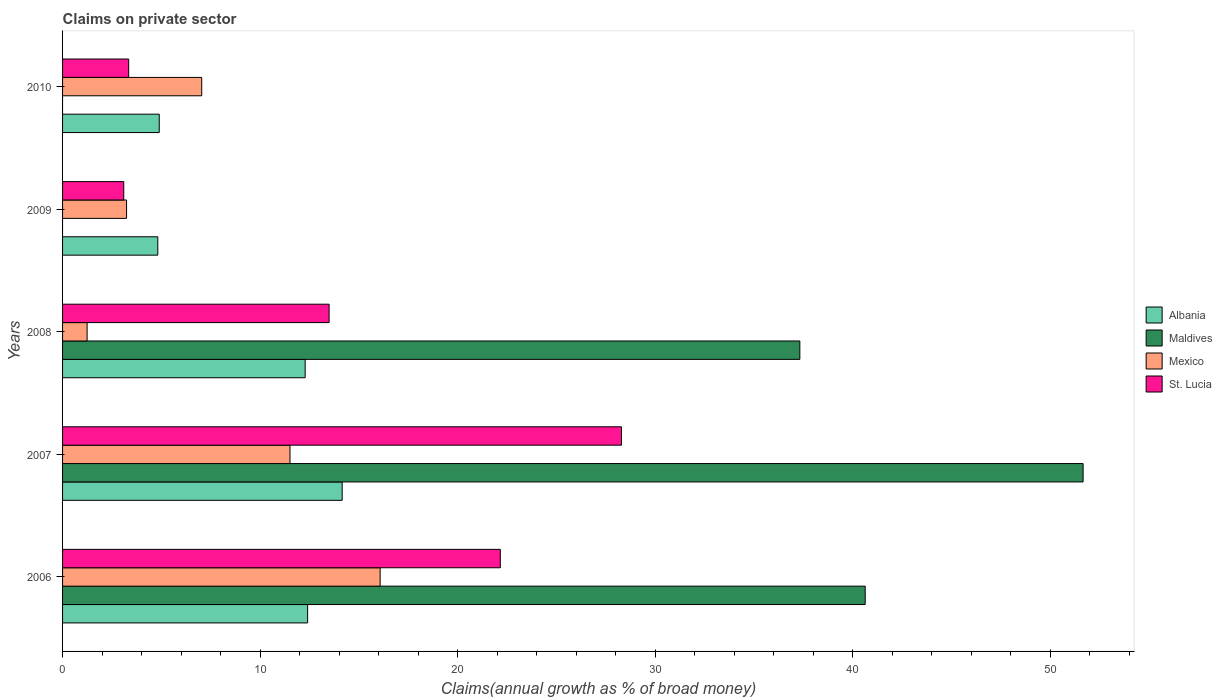How many different coloured bars are there?
Your answer should be very brief. 4. Are the number of bars per tick equal to the number of legend labels?
Keep it short and to the point. No. Are the number of bars on each tick of the Y-axis equal?
Ensure brevity in your answer.  No. How many bars are there on the 1st tick from the top?
Give a very brief answer. 3. How many bars are there on the 4th tick from the bottom?
Give a very brief answer. 3. In how many cases, is the number of bars for a given year not equal to the number of legend labels?
Your answer should be compact. 2. What is the percentage of broad money claimed on private sector in St. Lucia in 2008?
Your answer should be compact. 13.49. Across all years, what is the maximum percentage of broad money claimed on private sector in St. Lucia?
Provide a succinct answer. 28.29. Across all years, what is the minimum percentage of broad money claimed on private sector in Mexico?
Your response must be concise. 1.24. In which year was the percentage of broad money claimed on private sector in Albania maximum?
Offer a terse response. 2007. What is the total percentage of broad money claimed on private sector in Maldives in the graph?
Your response must be concise. 129.62. What is the difference between the percentage of broad money claimed on private sector in Maldives in 2006 and that in 2008?
Your response must be concise. 3.31. What is the difference between the percentage of broad money claimed on private sector in Maldives in 2006 and the percentage of broad money claimed on private sector in St. Lucia in 2009?
Offer a terse response. 37.53. What is the average percentage of broad money claimed on private sector in Albania per year?
Offer a terse response. 9.71. In the year 2006, what is the difference between the percentage of broad money claimed on private sector in Mexico and percentage of broad money claimed on private sector in Albania?
Ensure brevity in your answer.  3.67. What is the ratio of the percentage of broad money claimed on private sector in Mexico in 2006 to that in 2007?
Ensure brevity in your answer.  1.4. Is the percentage of broad money claimed on private sector in Albania in 2006 less than that in 2009?
Give a very brief answer. No. Is the difference between the percentage of broad money claimed on private sector in Mexico in 2008 and 2010 greater than the difference between the percentage of broad money claimed on private sector in Albania in 2008 and 2010?
Offer a very short reply. No. What is the difference between the highest and the second highest percentage of broad money claimed on private sector in Mexico?
Provide a succinct answer. 4.56. What is the difference between the highest and the lowest percentage of broad money claimed on private sector in Mexico?
Keep it short and to the point. 14.83. In how many years, is the percentage of broad money claimed on private sector in St. Lucia greater than the average percentage of broad money claimed on private sector in St. Lucia taken over all years?
Your answer should be very brief. 2. Is the sum of the percentage of broad money claimed on private sector in St. Lucia in 2007 and 2008 greater than the maximum percentage of broad money claimed on private sector in Albania across all years?
Offer a terse response. Yes. Is it the case that in every year, the sum of the percentage of broad money claimed on private sector in Albania and percentage of broad money claimed on private sector in Maldives is greater than the percentage of broad money claimed on private sector in St. Lucia?
Provide a short and direct response. Yes. What is the difference between two consecutive major ticks on the X-axis?
Provide a succinct answer. 10. Are the values on the major ticks of X-axis written in scientific E-notation?
Your answer should be very brief. No. Does the graph contain grids?
Offer a very short reply. No. Where does the legend appear in the graph?
Ensure brevity in your answer.  Center right. How many legend labels are there?
Ensure brevity in your answer.  4. How are the legend labels stacked?
Offer a very short reply. Vertical. What is the title of the graph?
Give a very brief answer. Claims on private sector. What is the label or title of the X-axis?
Your answer should be compact. Claims(annual growth as % of broad money). What is the Claims(annual growth as % of broad money) in Albania in 2006?
Offer a very short reply. 12.41. What is the Claims(annual growth as % of broad money) in Maldives in 2006?
Your answer should be compact. 40.63. What is the Claims(annual growth as % of broad money) of Mexico in 2006?
Offer a terse response. 16.08. What is the Claims(annual growth as % of broad money) of St. Lucia in 2006?
Ensure brevity in your answer.  22.16. What is the Claims(annual growth as % of broad money) in Albania in 2007?
Your answer should be compact. 14.15. What is the Claims(annual growth as % of broad money) of Maldives in 2007?
Your answer should be compact. 51.66. What is the Claims(annual growth as % of broad money) of Mexico in 2007?
Make the answer very short. 11.51. What is the Claims(annual growth as % of broad money) in St. Lucia in 2007?
Provide a succinct answer. 28.29. What is the Claims(annual growth as % of broad money) in Albania in 2008?
Offer a terse response. 12.28. What is the Claims(annual growth as % of broad money) in Maldives in 2008?
Your answer should be very brief. 37.32. What is the Claims(annual growth as % of broad money) in Mexico in 2008?
Make the answer very short. 1.24. What is the Claims(annual growth as % of broad money) of St. Lucia in 2008?
Make the answer very short. 13.49. What is the Claims(annual growth as % of broad money) in Albania in 2009?
Offer a very short reply. 4.82. What is the Claims(annual growth as % of broad money) in Maldives in 2009?
Your answer should be compact. 0. What is the Claims(annual growth as % of broad money) of Mexico in 2009?
Give a very brief answer. 3.24. What is the Claims(annual growth as % of broad money) in St. Lucia in 2009?
Your answer should be very brief. 3.1. What is the Claims(annual growth as % of broad money) of Albania in 2010?
Make the answer very short. 4.89. What is the Claims(annual growth as % of broad money) in Mexico in 2010?
Provide a short and direct response. 7.04. What is the Claims(annual growth as % of broad money) in St. Lucia in 2010?
Offer a very short reply. 3.35. Across all years, what is the maximum Claims(annual growth as % of broad money) of Albania?
Provide a short and direct response. 14.15. Across all years, what is the maximum Claims(annual growth as % of broad money) in Maldives?
Offer a very short reply. 51.66. Across all years, what is the maximum Claims(annual growth as % of broad money) of Mexico?
Your answer should be compact. 16.08. Across all years, what is the maximum Claims(annual growth as % of broad money) in St. Lucia?
Make the answer very short. 28.29. Across all years, what is the minimum Claims(annual growth as % of broad money) of Albania?
Give a very brief answer. 4.82. Across all years, what is the minimum Claims(annual growth as % of broad money) of Mexico?
Provide a short and direct response. 1.24. Across all years, what is the minimum Claims(annual growth as % of broad money) of St. Lucia?
Give a very brief answer. 3.1. What is the total Claims(annual growth as % of broad money) in Albania in the graph?
Ensure brevity in your answer.  48.56. What is the total Claims(annual growth as % of broad money) of Maldives in the graph?
Ensure brevity in your answer.  129.62. What is the total Claims(annual growth as % of broad money) in Mexico in the graph?
Your answer should be very brief. 39.11. What is the total Claims(annual growth as % of broad money) of St. Lucia in the graph?
Your answer should be very brief. 70.39. What is the difference between the Claims(annual growth as % of broad money) in Albania in 2006 and that in 2007?
Provide a short and direct response. -1.75. What is the difference between the Claims(annual growth as % of broad money) in Maldives in 2006 and that in 2007?
Provide a short and direct response. -11.03. What is the difference between the Claims(annual growth as % of broad money) of Mexico in 2006 and that in 2007?
Your answer should be very brief. 4.56. What is the difference between the Claims(annual growth as % of broad money) in St. Lucia in 2006 and that in 2007?
Your answer should be very brief. -6.13. What is the difference between the Claims(annual growth as % of broad money) in Albania in 2006 and that in 2008?
Your answer should be very brief. 0.12. What is the difference between the Claims(annual growth as % of broad money) in Maldives in 2006 and that in 2008?
Your answer should be compact. 3.31. What is the difference between the Claims(annual growth as % of broad money) of Mexico in 2006 and that in 2008?
Give a very brief answer. 14.83. What is the difference between the Claims(annual growth as % of broad money) of St. Lucia in 2006 and that in 2008?
Keep it short and to the point. 8.67. What is the difference between the Claims(annual growth as % of broad money) in Albania in 2006 and that in 2009?
Your answer should be compact. 7.58. What is the difference between the Claims(annual growth as % of broad money) of Mexico in 2006 and that in 2009?
Ensure brevity in your answer.  12.84. What is the difference between the Claims(annual growth as % of broad money) of St. Lucia in 2006 and that in 2009?
Ensure brevity in your answer.  19.06. What is the difference between the Claims(annual growth as % of broad money) of Albania in 2006 and that in 2010?
Your answer should be very brief. 7.51. What is the difference between the Claims(annual growth as % of broad money) of Mexico in 2006 and that in 2010?
Provide a succinct answer. 9.03. What is the difference between the Claims(annual growth as % of broad money) of St. Lucia in 2006 and that in 2010?
Your answer should be very brief. 18.81. What is the difference between the Claims(annual growth as % of broad money) in Albania in 2007 and that in 2008?
Offer a very short reply. 1.87. What is the difference between the Claims(annual growth as % of broad money) in Maldives in 2007 and that in 2008?
Provide a succinct answer. 14.34. What is the difference between the Claims(annual growth as % of broad money) in Mexico in 2007 and that in 2008?
Your answer should be very brief. 10.27. What is the difference between the Claims(annual growth as % of broad money) in St. Lucia in 2007 and that in 2008?
Offer a very short reply. 14.8. What is the difference between the Claims(annual growth as % of broad money) in Albania in 2007 and that in 2009?
Provide a succinct answer. 9.33. What is the difference between the Claims(annual growth as % of broad money) in Mexico in 2007 and that in 2009?
Offer a very short reply. 8.27. What is the difference between the Claims(annual growth as % of broad money) of St. Lucia in 2007 and that in 2009?
Give a very brief answer. 25.19. What is the difference between the Claims(annual growth as % of broad money) in Albania in 2007 and that in 2010?
Offer a very short reply. 9.26. What is the difference between the Claims(annual growth as % of broad money) of Mexico in 2007 and that in 2010?
Offer a terse response. 4.47. What is the difference between the Claims(annual growth as % of broad money) in St. Lucia in 2007 and that in 2010?
Your answer should be compact. 24.94. What is the difference between the Claims(annual growth as % of broad money) of Albania in 2008 and that in 2009?
Your answer should be compact. 7.46. What is the difference between the Claims(annual growth as % of broad money) in Mexico in 2008 and that in 2009?
Your answer should be compact. -2. What is the difference between the Claims(annual growth as % of broad money) of St. Lucia in 2008 and that in 2009?
Your answer should be very brief. 10.4. What is the difference between the Claims(annual growth as % of broad money) of Albania in 2008 and that in 2010?
Provide a succinct answer. 7.39. What is the difference between the Claims(annual growth as % of broad money) of Mexico in 2008 and that in 2010?
Offer a terse response. -5.8. What is the difference between the Claims(annual growth as % of broad money) of St. Lucia in 2008 and that in 2010?
Give a very brief answer. 10.15. What is the difference between the Claims(annual growth as % of broad money) in Albania in 2009 and that in 2010?
Keep it short and to the point. -0.07. What is the difference between the Claims(annual growth as % of broad money) in Mexico in 2009 and that in 2010?
Your response must be concise. -3.8. What is the difference between the Claims(annual growth as % of broad money) of St. Lucia in 2009 and that in 2010?
Give a very brief answer. -0.25. What is the difference between the Claims(annual growth as % of broad money) in Albania in 2006 and the Claims(annual growth as % of broad money) in Maldives in 2007?
Make the answer very short. -39.26. What is the difference between the Claims(annual growth as % of broad money) in Albania in 2006 and the Claims(annual growth as % of broad money) in Mexico in 2007?
Make the answer very short. 0.89. What is the difference between the Claims(annual growth as % of broad money) of Albania in 2006 and the Claims(annual growth as % of broad money) of St. Lucia in 2007?
Offer a very short reply. -15.89. What is the difference between the Claims(annual growth as % of broad money) of Maldives in 2006 and the Claims(annual growth as % of broad money) of Mexico in 2007?
Your response must be concise. 29.12. What is the difference between the Claims(annual growth as % of broad money) of Maldives in 2006 and the Claims(annual growth as % of broad money) of St. Lucia in 2007?
Provide a succinct answer. 12.34. What is the difference between the Claims(annual growth as % of broad money) in Mexico in 2006 and the Claims(annual growth as % of broad money) in St. Lucia in 2007?
Provide a short and direct response. -12.21. What is the difference between the Claims(annual growth as % of broad money) of Albania in 2006 and the Claims(annual growth as % of broad money) of Maldives in 2008?
Offer a very short reply. -24.92. What is the difference between the Claims(annual growth as % of broad money) in Albania in 2006 and the Claims(annual growth as % of broad money) in Mexico in 2008?
Offer a terse response. 11.16. What is the difference between the Claims(annual growth as % of broad money) of Albania in 2006 and the Claims(annual growth as % of broad money) of St. Lucia in 2008?
Provide a succinct answer. -1.09. What is the difference between the Claims(annual growth as % of broad money) of Maldives in 2006 and the Claims(annual growth as % of broad money) of Mexico in 2008?
Provide a short and direct response. 39.39. What is the difference between the Claims(annual growth as % of broad money) in Maldives in 2006 and the Claims(annual growth as % of broad money) in St. Lucia in 2008?
Provide a short and direct response. 27.14. What is the difference between the Claims(annual growth as % of broad money) of Mexico in 2006 and the Claims(annual growth as % of broad money) of St. Lucia in 2008?
Ensure brevity in your answer.  2.58. What is the difference between the Claims(annual growth as % of broad money) in Albania in 2006 and the Claims(annual growth as % of broad money) in Mexico in 2009?
Provide a short and direct response. 9.17. What is the difference between the Claims(annual growth as % of broad money) of Albania in 2006 and the Claims(annual growth as % of broad money) of St. Lucia in 2009?
Your answer should be very brief. 9.31. What is the difference between the Claims(annual growth as % of broad money) of Maldives in 2006 and the Claims(annual growth as % of broad money) of Mexico in 2009?
Ensure brevity in your answer.  37.39. What is the difference between the Claims(annual growth as % of broad money) in Maldives in 2006 and the Claims(annual growth as % of broad money) in St. Lucia in 2009?
Provide a short and direct response. 37.53. What is the difference between the Claims(annual growth as % of broad money) in Mexico in 2006 and the Claims(annual growth as % of broad money) in St. Lucia in 2009?
Ensure brevity in your answer.  12.98. What is the difference between the Claims(annual growth as % of broad money) in Albania in 2006 and the Claims(annual growth as % of broad money) in Mexico in 2010?
Your response must be concise. 5.36. What is the difference between the Claims(annual growth as % of broad money) in Albania in 2006 and the Claims(annual growth as % of broad money) in St. Lucia in 2010?
Make the answer very short. 9.06. What is the difference between the Claims(annual growth as % of broad money) in Maldives in 2006 and the Claims(annual growth as % of broad money) in Mexico in 2010?
Offer a very short reply. 33.59. What is the difference between the Claims(annual growth as % of broad money) in Maldives in 2006 and the Claims(annual growth as % of broad money) in St. Lucia in 2010?
Make the answer very short. 37.28. What is the difference between the Claims(annual growth as % of broad money) in Mexico in 2006 and the Claims(annual growth as % of broad money) in St. Lucia in 2010?
Your answer should be very brief. 12.73. What is the difference between the Claims(annual growth as % of broad money) in Albania in 2007 and the Claims(annual growth as % of broad money) in Maldives in 2008?
Your answer should be very brief. -23.17. What is the difference between the Claims(annual growth as % of broad money) in Albania in 2007 and the Claims(annual growth as % of broad money) in Mexico in 2008?
Make the answer very short. 12.91. What is the difference between the Claims(annual growth as % of broad money) in Albania in 2007 and the Claims(annual growth as % of broad money) in St. Lucia in 2008?
Your response must be concise. 0.66. What is the difference between the Claims(annual growth as % of broad money) in Maldives in 2007 and the Claims(annual growth as % of broad money) in Mexico in 2008?
Provide a short and direct response. 50.42. What is the difference between the Claims(annual growth as % of broad money) of Maldives in 2007 and the Claims(annual growth as % of broad money) of St. Lucia in 2008?
Your answer should be compact. 38.17. What is the difference between the Claims(annual growth as % of broad money) of Mexico in 2007 and the Claims(annual growth as % of broad money) of St. Lucia in 2008?
Provide a short and direct response. -1.98. What is the difference between the Claims(annual growth as % of broad money) in Albania in 2007 and the Claims(annual growth as % of broad money) in Mexico in 2009?
Give a very brief answer. 10.92. What is the difference between the Claims(annual growth as % of broad money) in Albania in 2007 and the Claims(annual growth as % of broad money) in St. Lucia in 2009?
Give a very brief answer. 11.06. What is the difference between the Claims(annual growth as % of broad money) of Maldives in 2007 and the Claims(annual growth as % of broad money) of Mexico in 2009?
Make the answer very short. 48.42. What is the difference between the Claims(annual growth as % of broad money) in Maldives in 2007 and the Claims(annual growth as % of broad money) in St. Lucia in 2009?
Keep it short and to the point. 48.56. What is the difference between the Claims(annual growth as % of broad money) in Mexico in 2007 and the Claims(annual growth as % of broad money) in St. Lucia in 2009?
Make the answer very short. 8.42. What is the difference between the Claims(annual growth as % of broad money) in Albania in 2007 and the Claims(annual growth as % of broad money) in Mexico in 2010?
Offer a terse response. 7.11. What is the difference between the Claims(annual growth as % of broad money) of Albania in 2007 and the Claims(annual growth as % of broad money) of St. Lucia in 2010?
Ensure brevity in your answer.  10.81. What is the difference between the Claims(annual growth as % of broad money) in Maldives in 2007 and the Claims(annual growth as % of broad money) in Mexico in 2010?
Offer a terse response. 44.62. What is the difference between the Claims(annual growth as % of broad money) in Maldives in 2007 and the Claims(annual growth as % of broad money) in St. Lucia in 2010?
Offer a terse response. 48.32. What is the difference between the Claims(annual growth as % of broad money) in Mexico in 2007 and the Claims(annual growth as % of broad money) in St. Lucia in 2010?
Provide a short and direct response. 8.17. What is the difference between the Claims(annual growth as % of broad money) in Albania in 2008 and the Claims(annual growth as % of broad money) in Mexico in 2009?
Provide a succinct answer. 9.04. What is the difference between the Claims(annual growth as % of broad money) in Albania in 2008 and the Claims(annual growth as % of broad money) in St. Lucia in 2009?
Keep it short and to the point. 9.18. What is the difference between the Claims(annual growth as % of broad money) of Maldives in 2008 and the Claims(annual growth as % of broad money) of Mexico in 2009?
Your response must be concise. 34.08. What is the difference between the Claims(annual growth as % of broad money) in Maldives in 2008 and the Claims(annual growth as % of broad money) in St. Lucia in 2009?
Give a very brief answer. 34.23. What is the difference between the Claims(annual growth as % of broad money) of Mexico in 2008 and the Claims(annual growth as % of broad money) of St. Lucia in 2009?
Your response must be concise. -1.85. What is the difference between the Claims(annual growth as % of broad money) in Albania in 2008 and the Claims(annual growth as % of broad money) in Mexico in 2010?
Your answer should be very brief. 5.24. What is the difference between the Claims(annual growth as % of broad money) in Albania in 2008 and the Claims(annual growth as % of broad money) in St. Lucia in 2010?
Your response must be concise. 8.93. What is the difference between the Claims(annual growth as % of broad money) in Maldives in 2008 and the Claims(annual growth as % of broad money) in Mexico in 2010?
Your answer should be very brief. 30.28. What is the difference between the Claims(annual growth as % of broad money) in Maldives in 2008 and the Claims(annual growth as % of broad money) in St. Lucia in 2010?
Ensure brevity in your answer.  33.98. What is the difference between the Claims(annual growth as % of broad money) of Mexico in 2008 and the Claims(annual growth as % of broad money) of St. Lucia in 2010?
Make the answer very short. -2.1. What is the difference between the Claims(annual growth as % of broad money) of Albania in 2009 and the Claims(annual growth as % of broad money) of Mexico in 2010?
Your answer should be very brief. -2.22. What is the difference between the Claims(annual growth as % of broad money) in Albania in 2009 and the Claims(annual growth as % of broad money) in St. Lucia in 2010?
Your answer should be very brief. 1.47. What is the difference between the Claims(annual growth as % of broad money) of Mexico in 2009 and the Claims(annual growth as % of broad money) of St. Lucia in 2010?
Offer a terse response. -0.11. What is the average Claims(annual growth as % of broad money) of Albania per year?
Ensure brevity in your answer.  9.71. What is the average Claims(annual growth as % of broad money) in Maldives per year?
Ensure brevity in your answer.  25.92. What is the average Claims(annual growth as % of broad money) of Mexico per year?
Your response must be concise. 7.82. What is the average Claims(annual growth as % of broad money) of St. Lucia per year?
Give a very brief answer. 14.08. In the year 2006, what is the difference between the Claims(annual growth as % of broad money) of Albania and Claims(annual growth as % of broad money) of Maldives?
Ensure brevity in your answer.  -28.23. In the year 2006, what is the difference between the Claims(annual growth as % of broad money) of Albania and Claims(annual growth as % of broad money) of Mexico?
Your response must be concise. -3.67. In the year 2006, what is the difference between the Claims(annual growth as % of broad money) in Albania and Claims(annual growth as % of broad money) in St. Lucia?
Make the answer very short. -9.75. In the year 2006, what is the difference between the Claims(annual growth as % of broad money) in Maldives and Claims(annual growth as % of broad money) in Mexico?
Provide a succinct answer. 24.56. In the year 2006, what is the difference between the Claims(annual growth as % of broad money) in Maldives and Claims(annual growth as % of broad money) in St. Lucia?
Ensure brevity in your answer.  18.47. In the year 2006, what is the difference between the Claims(annual growth as % of broad money) in Mexico and Claims(annual growth as % of broad money) in St. Lucia?
Your answer should be very brief. -6.08. In the year 2007, what is the difference between the Claims(annual growth as % of broad money) of Albania and Claims(annual growth as % of broad money) of Maldives?
Ensure brevity in your answer.  -37.51. In the year 2007, what is the difference between the Claims(annual growth as % of broad money) of Albania and Claims(annual growth as % of broad money) of Mexico?
Keep it short and to the point. 2.64. In the year 2007, what is the difference between the Claims(annual growth as % of broad money) of Albania and Claims(annual growth as % of broad money) of St. Lucia?
Provide a short and direct response. -14.14. In the year 2007, what is the difference between the Claims(annual growth as % of broad money) of Maldives and Claims(annual growth as % of broad money) of Mexico?
Your response must be concise. 40.15. In the year 2007, what is the difference between the Claims(annual growth as % of broad money) of Maldives and Claims(annual growth as % of broad money) of St. Lucia?
Offer a terse response. 23.37. In the year 2007, what is the difference between the Claims(annual growth as % of broad money) in Mexico and Claims(annual growth as % of broad money) in St. Lucia?
Provide a short and direct response. -16.78. In the year 2008, what is the difference between the Claims(annual growth as % of broad money) of Albania and Claims(annual growth as % of broad money) of Maldives?
Your response must be concise. -25.04. In the year 2008, what is the difference between the Claims(annual growth as % of broad money) of Albania and Claims(annual growth as % of broad money) of Mexico?
Give a very brief answer. 11.04. In the year 2008, what is the difference between the Claims(annual growth as % of broad money) in Albania and Claims(annual growth as % of broad money) in St. Lucia?
Offer a terse response. -1.21. In the year 2008, what is the difference between the Claims(annual growth as % of broad money) in Maldives and Claims(annual growth as % of broad money) in Mexico?
Offer a very short reply. 36.08. In the year 2008, what is the difference between the Claims(annual growth as % of broad money) in Maldives and Claims(annual growth as % of broad money) in St. Lucia?
Make the answer very short. 23.83. In the year 2008, what is the difference between the Claims(annual growth as % of broad money) of Mexico and Claims(annual growth as % of broad money) of St. Lucia?
Your response must be concise. -12.25. In the year 2009, what is the difference between the Claims(annual growth as % of broad money) in Albania and Claims(annual growth as % of broad money) in Mexico?
Provide a succinct answer. 1.58. In the year 2009, what is the difference between the Claims(annual growth as % of broad money) in Albania and Claims(annual growth as % of broad money) in St. Lucia?
Offer a very short reply. 1.72. In the year 2009, what is the difference between the Claims(annual growth as % of broad money) in Mexico and Claims(annual growth as % of broad money) in St. Lucia?
Offer a very short reply. 0.14. In the year 2010, what is the difference between the Claims(annual growth as % of broad money) in Albania and Claims(annual growth as % of broad money) in Mexico?
Your response must be concise. -2.15. In the year 2010, what is the difference between the Claims(annual growth as % of broad money) in Albania and Claims(annual growth as % of broad money) in St. Lucia?
Provide a succinct answer. 1.55. In the year 2010, what is the difference between the Claims(annual growth as % of broad money) in Mexico and Claims(annual growth as % of broad money) in St. Lucia?
Make the answer very short. 3.7. What is the ratio of the Claims(annual growth as % of broad money) in Albania in 2006 to that in 2007?
Offer a very short reply. 0.88. What is the ratio of the Claims(annual growth as % of broad money) of Maldives in 2006 to that in 2007?
Provide a short and direct response. 0.79. What is the ratio of the Claims(annual growth as % of broad money) of Mexico in 2006 to that in 2007?
Keep it short and to the point. 1.4. What is the ratio of the Claims(annual growth as % of broad money) of St. Lucia in 2006 to that in 2007?
Make the answer very short. 0.78. What is the ratio of the Claims(annual growth as % of broad money) in Albania in 2006 to that in 2008?
Provide a short and direct response. 1.01. What is the ratio of the Claims(annual growth as % of broad money) in Maldives in 2006 to that in 2008?
Offer a very short reply. 1.09. What is the ratio of the Claims(annual growth as % of broad money) of Mexico in 2006 to that in 2008?
Make the answer very short. 12.94. What is the ratio of the Claims(annual growth as % of broad money) of St. Lucia in 2006 to that in 2008?
Your response must be concise. 1.64. What is the ratio of the Claims(annual growth as % of broad money) of Albania in 2006 to that in 2009?
Provide a succinct answer. 2.57. What is the ratio of the Claims(annual growth as % of broad money) in Mexico in 2006 to that in 2009?
Provide a short and direct response. 4.96. What is the ratio of the Claims(annual growth as % of broad money) of St. Lucia in 2006 to that in 2009?
Provide a succinct answer. 7.16. What is the ratio of the Claims(annual growth as % of broad money) of Albania in 2006 to that in 2010?
Provide a succinct answer. 2.53. What is the ratio of the Claims(annual growth as % of broad money) of Mexico in 2006 to that in 2010?
Make the answer very short. 2.28. What is the ratio of the Claims(annual growth as % of broad money) in St. Lucia in 2006 to that in 2010?
Your response must be concise. 6.62. What is the ratio of the Claims(annual growth as % of broad money) of Albania in 2007 to that in 2008?
Provide a short and direct response. 1.15. What is the ratio of the Claims(annual growth as % of broad money) in Maldives in 2007 to that in 2008?
Your answer should be compact. 1.38. What is the ratio of the Claims(annual growth as % of broad money) of Mexico in 2007 to that in 2008?
Make the answer very short. 9.27. What is the ratio of the Claims(annual growth as % of broad money) in St. Lucia in 2007 to that in 2008?
Provide a short and direct response. 2.1. What is the ratio of the Claims(annual growth as % of broad money) in Albania in 2007 to that in 2009?
Make the answer very short. 2.94. What is the ratio of the Claims(annual growth as % of broad money) of Mexico in 2007 to that in 2009?
Your response must be concise. 3.55. What is the ratio of the Claims(annual growth as % of broad money) in St. Lucia in 2007 to that in 2009?
Offer a terse response. 9.13. What is the ratio of the Claims(annual growth as % of broad money) in Albania in 2007 to that in 2010?
Offer a very short reply. 2.89. What is the ratio of the Claims(annual growth as % of broad money) in Mexico in 2007 to that in 2010?
Provide a short and direct response. 1.63. What is the ratio of the Claims(annual growth as % of broad money) in St. Lucia in 2007 to that in 2010?
Your answer should be compact. 8.45. What is the ratio of the Claims(annual growth as % of broad money) in Albania in 2008 to that in 2009?
Keep it short and to the point. 2.55. What is the ratio of the Claims(annual growth as % of broad money) in Mexico in 2008 to that in 2009?
Offer a very short reply. 0.38. What is the ratio of the Claims(annual growth as % of broad money) in St. Lucia in 2008 to that in 2009?
Your answer should be compact. 4.36. What is the ratio of the Claims(annual growth as % of broad money) of Albania in 2008 to that in 2010?
Your answer should be very brief. 2.51. What is the ratio of the Claims(annual growth as % of broad money) of Mexico in 2008 to that in 2010?
Your answer should be compact. 0.18. What is the ratio of the Claims(annual growth as % of broad money) of St. Lucia in 2008 to that in 2010?
Offer a very short reply. 4.03. What is the ratio of the Claims(annual growth as % of broad money) of Albania in 2009 to that in 2010?
Provide a short and direct response. 0.98. What is the ratio of the Claims(annual growth as % of broad money) of Mexico in 2009 to that in 2010?
Your response must be concise. 0.46. What is the ratio of the Claims(annual growth as % of broad money) of St. Lucia in 2009 to that in 2010?
Make the answer very short. 0.93. What is the difference between the highest and the second highest Claims(annual growth as % of broad money) of Albania?
Provide a short and direct response. 1.75. What is the difference between the highest and the second highest Claims(annual growth as % of broad money) of Maldives?
Ensure brevity in your answer.  11.03. What is the difference between the highest and the second highest Claims(annual growth as % of broad money) of Mexico?
Your answer should be very brief. 4.56. What is the difference between the highest and the second highest Claims(annual growth as % of broad money) in St. Lucia?
Keep it short and to the point. 6.13. What is the difference between the highest and the lowest Claims(annual growth as % of broad money) in Albania?
Make the answer very short. 9.33. What is the difference between the highest and the lowest Claims(annual growth as % of broad money) of Maldives?
Make the answer very short. 51.66. What is the difference between the highest and the lowest Claims(annual growth as % of broad money) in Mexico?
Keep it short and to the point. 14.83. What is the difference between the highest and the lowest Claims(annual growth as % of broad money) of St. Lucia?
Your answer should be compact. 25.19. 